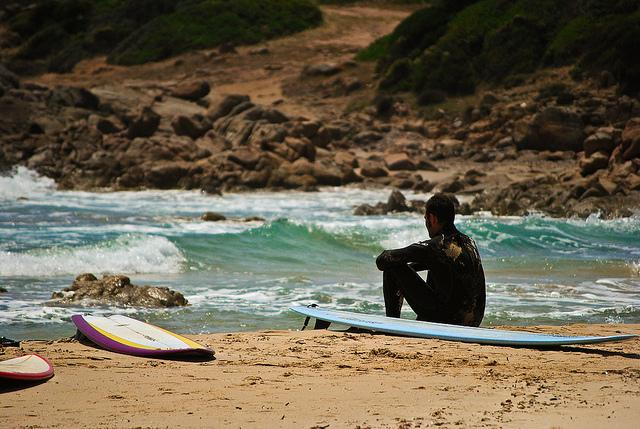What was the man just doing? Please explain your reasoning. lying down. The man is lying down. 